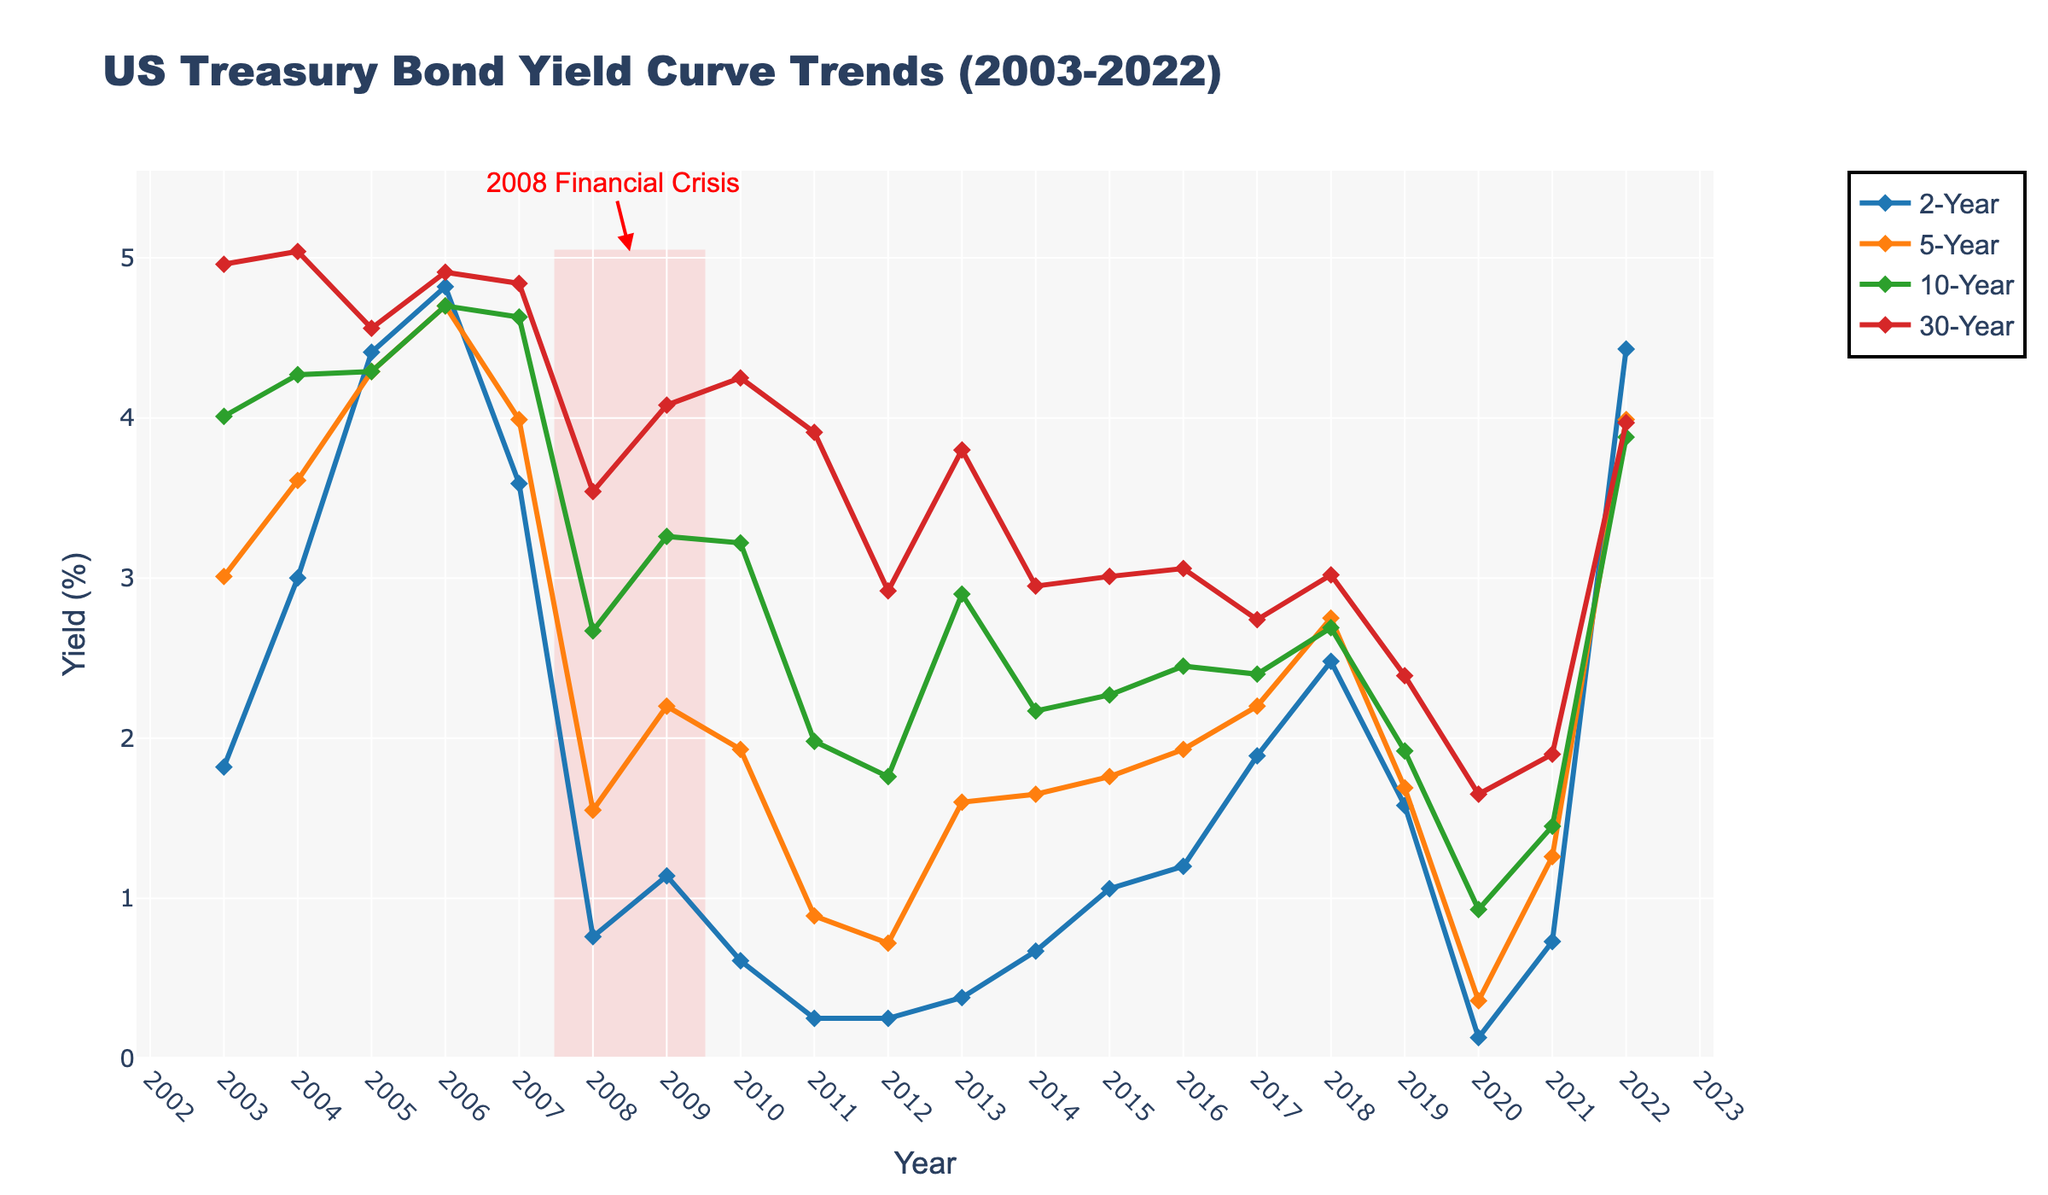What's the highest yield recorded for the 10-Year bond, and when did it occur? To find the highest yield of the 10-Year bond, look for the peak point in the 10-Year series. The value with the highest point on the chart is 4.70 in 2006.
Answer: 4.70 in 2006 During which year was the 5-Year yield closest to the 2-Year yield? Compare the yields for the 5-Year and 2-Year bonds on a year-by-year basis to see where the smallest difference occurs. In 2005, the yields are 4.29 for both bonds.
Answer: 2005 In which year did the 2-Year yield see the most significant increase compared to the previous year? Examine the year-to-year changes for the 2-Year yield. The most substantial increase is from 2021 (0.73) to 2022 (4.43), which is an increase of 3.70.
Answer: 2022 How did the yields for all maturities behave during the 2008 financial crisis period (highlighted in red)? Observe the change in yields from 2007 to 2008 for all maturities. Each yield significantly dropped during this period. For example, the 2-Year yield dropped from 3.59 in 2007 to 0.76 in 2008. Similar drops are evident for the other yields.
Answer: All yields dropped Which bond maturity had the lowest yield in 2012 and what was its value? Compare the yields for all bond maturities in the year 2012. The 2-Year bond had the lowest yield at 0.25.
Answer: 2-Year, 0.25 What was the average yield for the 30-Year bond during the years 2010 to 2015? Calculate the average of the values from 2010 to 2015 for the 30-Year bond. Sum the yields (4.25, 3.91, 2.92, 3.80, 2.95, 3.01) which equals 20.84 and divide by 6 (number of years): 20.84 / 6 = 3.47.
Answer: 3.47 Which year shows the flattest yield curve, meaning the smallest difference between the 2-Year and 30-Year yields? Calculate the difference between the yields for these bonds for each year and find the year with the smallest difference. In 2017, the difference is smallest: 2.74 - 1.89 = 0.85.
Answer: 2017 During which two consecutive years did the 10-Year yield decrease the most? Check the year-to-year differences for the 10-Year yield and identify the two consecutive years with the largest drop. From 2018 (2.69) to 2019 (1.92) is the most considerable decrease, a drop of 0.77.
Answer: 2018 to 2019 How did the yield of the 5-Year bond change from 2019 to 2020, and what was the value of this change? Subtract the 2020 yield (0.36) from the 2019 yield (1.69). The change is 1.69 - 0.36 = 1.33.
Answer: Decreased by 1.33 Which bond maturity had the highest yield in 2022 and what was the value? Compare the yields for all maturities in the year 2022. The 2-Year bond had the highest yield at 4.43.
Answer: 2-Year, 4.43 